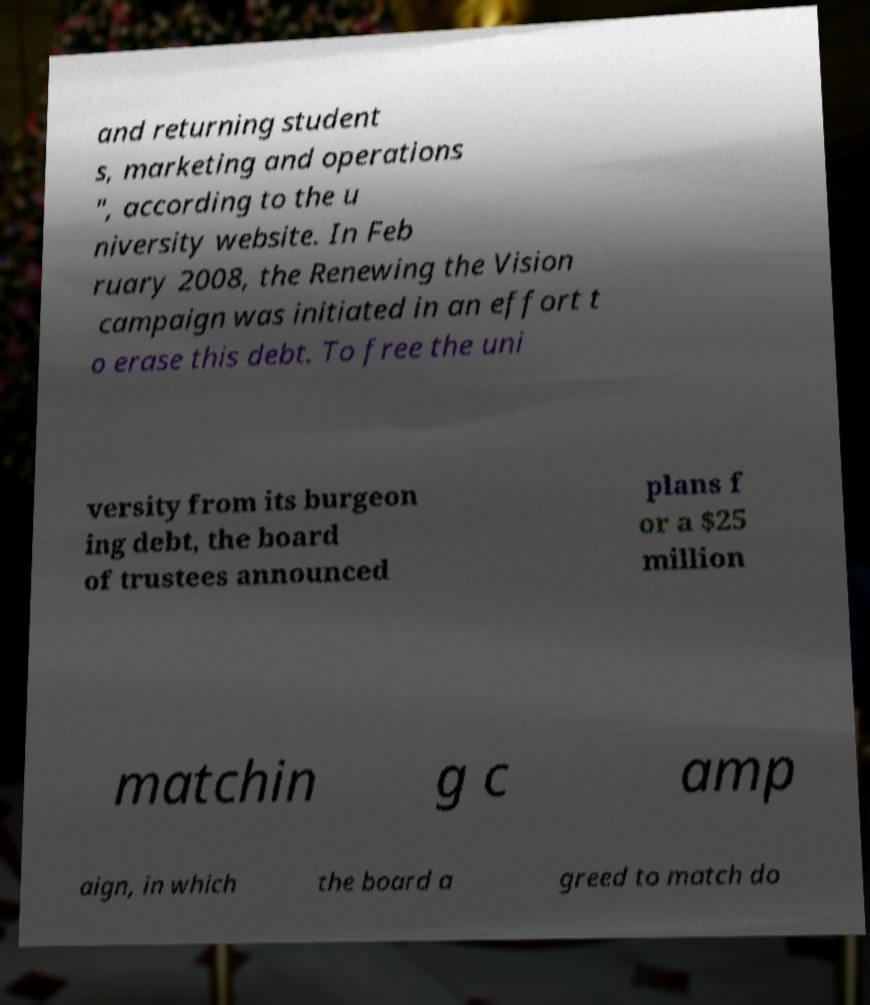Can you read and provide the text displayed in the image?This photo seems to have some interesting text. Can you extract and type it out for me? and returning student s, marketing and operations ", according to the u niversity website. In Feb ruary 2008, the Renewing the Vision campaign was initiated in an effort t o erase this debt. To free the uni versity from its burgeon ing debt, the board of trustees announced plans f or a $25 million matchin g c amp aign, in which the board a greed to match do 